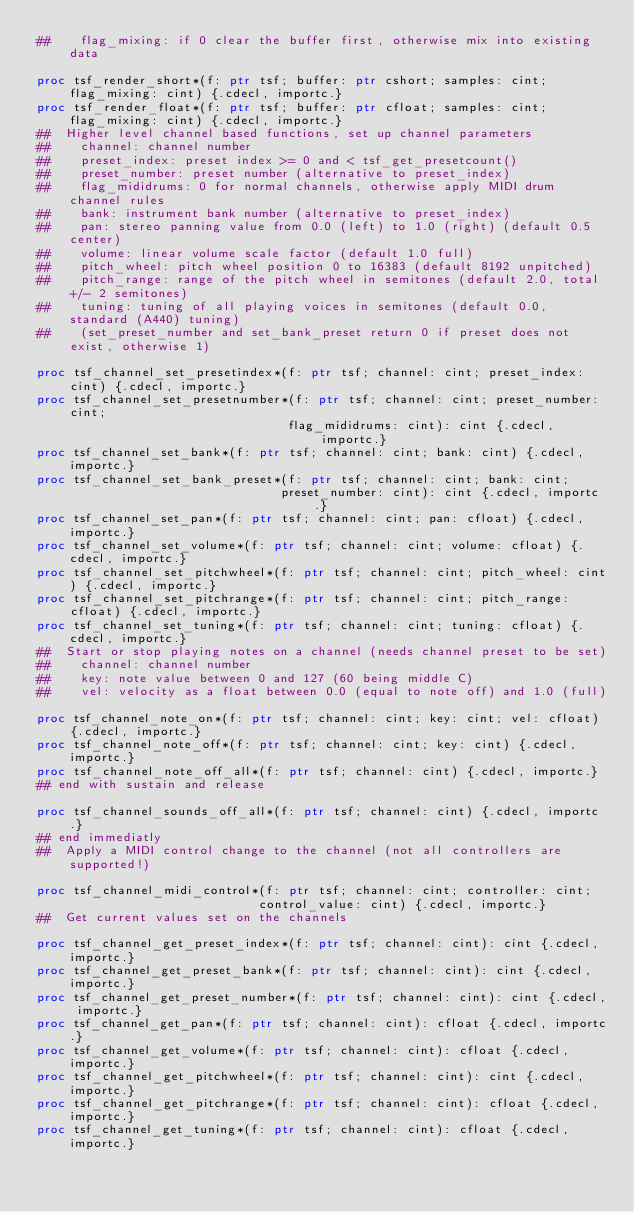Convert code to text. <code><loc_0><loc_0><loc_500><loc_500><_Nim_>##    flag_mixing: if 0 clear the buffer first, otherwise mix into existing data

proc tsf_render_short*(f: ptr tsf; buffer: ptr cshort; samples: cint; flag_mixing: cint) {.cdecl, importc.}
proc tsf_render_float*(f: ptr tsf; buffer: ptr cfloat; samples: cint; flag_mixing: cint) {.cdecl, importc.}
##  Higher level channel based functions, set up channel parameters
##    channel: channel number
##    preset_index: preset index >= 0 and < tsf_get_presetcount()
##    preset_number: preset number (alternative to preset_index)
##    flag_mididrums: 0 for normal channels, otherwise apply MIDI drum channel rules
##    bank: instrument bank number (alternative to preset_index)
##    pan: stereo panning value from 0.0 (left) to 1.0 (right) (default 0.5 center)
##    volume: linear volume scale factor (default 1.0 full)
##    pitch_wheel: pitch wheel position 0 to 16383 (default 8192 unpitched)
##    pitch_range: range of the pitch wheel in semitones (default 2.0, total +/- 2 semitones)
##    tuning: tuning of all playing voices in semitones (default 0.0, standard (A440) tuning)
##    (set_preset_number and set_bank_preset return 0 if preset does not exist, otherwise 1)

proc tsf_channel_set_presetindex*(f: ptr tsf; channel: cint; preset_index: cint) {.cdecl, importc.}
proc tsf_channel_set_presetnumber*(f: ptr tsf; channel: cint; preset_number: cint;
                                  flag_mididrums: cint): cint {.cdecl, importc.}
proc tsf_channel_set_bank*(f: ptr tsf; channel: cint; bank: cint) {.cdecl, importc.}
proc tsf_channel_set_bank_preset*(f: ptr tsf; channel: cint; bank: cint;
                                 preset_number: cint): cint {.cdecl, importc.}
proc tsf_channel_set_pan*(f: ptr tsf; channel: cint; pan: cfloat) {.cdecl, importc.}
proc tsf_channel_set_volume*(f: ptr tsf; channel: cint; volume: cfloat) {.cdecl, importc.}
proc tsf_channel_set_pitchwheel*(f: ptr tsf; channel: cint; pitch_wheel: cint) {.cdecl, importc.}
proc tsf_channel_set_pitchrange*(f: ptr tsf; channel: cint; pitch_range: cfloat) {.cdecl, importc.}
proc tsf_channel_set_tuning*(f: ptr tsf; channel: cint; tuning: cfloat) {.cdecl, importc.}
##  Start or stop playing notes on a channel (needs channel preset to be set)
##    channel: channel number
##    key: note value between 0 and 127 (60 being middle C)
##    vel: velocity as a float between 0.0 (equal to note off) and 1.0 (full)

proc tsf_channel_note_on*(f: ptr tsf; channel: cint; key: cint; vel: cfloat) {.cdecl, importc.}
proc tsf_channel_note_off*(f: ptr tsf; channel: cint; key: cint) {.cdecl, importc.}
proc tsf_channel_note_off_all*(f: ptr tsf; channel: cint) {.cdecl, importc.}
## end with sustain and release

proc tsf_channel_sounds_off_all*(f: ptr tsf; channel: cint) {.cdecl, importc.}
## end immediatly
##  Apply a MIDI control change to the channel (not all controllers are supported!)

proc tsf_channel_midi_control*(f: ptr tsf; channel: cint; controller: cint;
                              control_value: cint) {.cdecl, importc.}
##  Get current values set on the channels

proc tsf_channel_get_preset_index*(f: ptr tsf; channel: cint): cint {.cdecl, importc.}
proc tsf_channel_get_preset_bank*(f: ptr tsf; channel: cint): cint {.cdecl, importc.}
proc tsf_channel_get_preset_number*(f: ptr tsf; channel: cint): cint {.cdecl, importc.}
proc tsf_channel_get_pan*(f: ptr tsf; channel: cint): cfloat {.cdecl, importc.}
proc tsf_channel_get_volume*(f: ptr tsf; channel: cint): cfloat {.cdecl, importc.}
proc tsf_channel_get_pitchwheel*(f: ptr tsf; channel: cint): cint {.cdecl, importc.}
proc tsf_channel_get_pitchrange*(f: ptr tsf; channel: cint): cfloat {.cdecl, importc.}
proc tsf_channel_get_tuning*(f: ptr tsf; channel: cint): cfloat {.cdecl, importc.}
</code> 